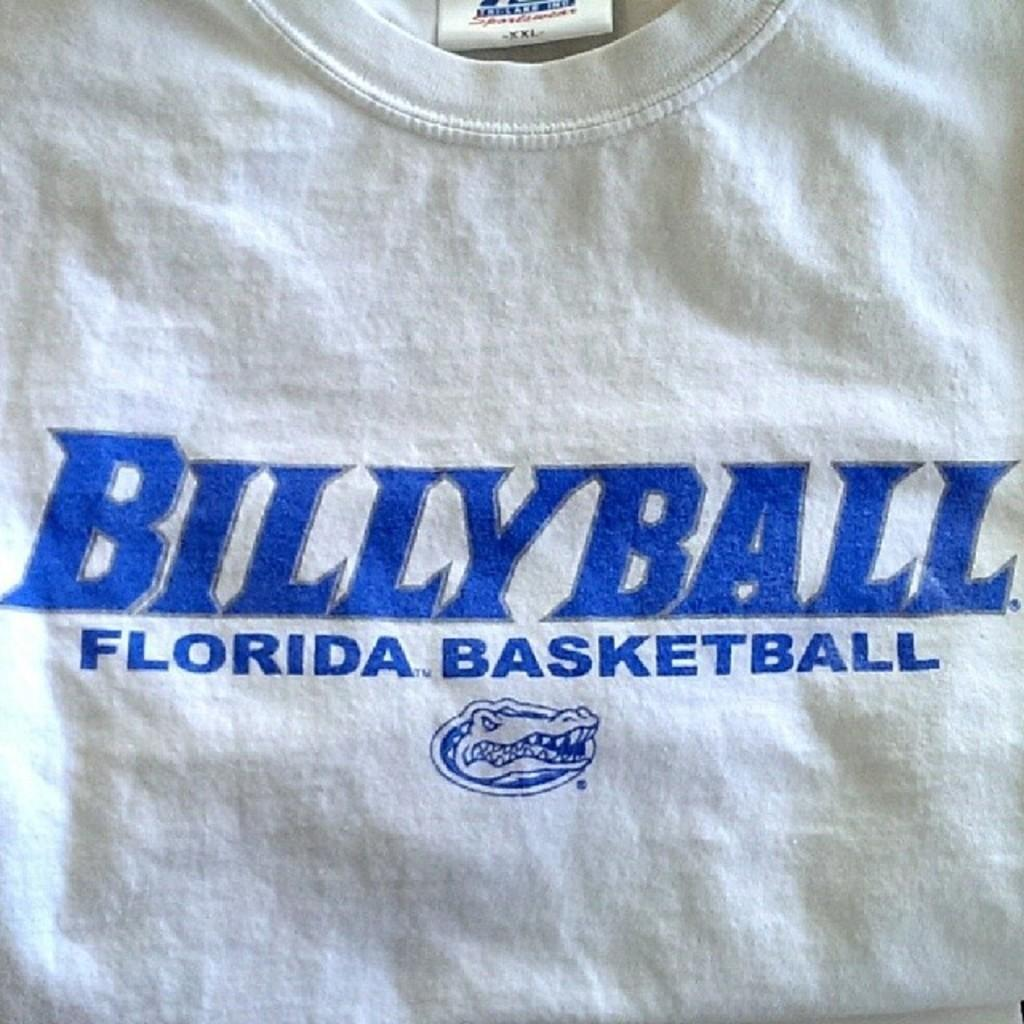<image>
Create a compact narrative representing the image presented. A white t-shirt depicting BillyBall Florida Basketball above a gator. 